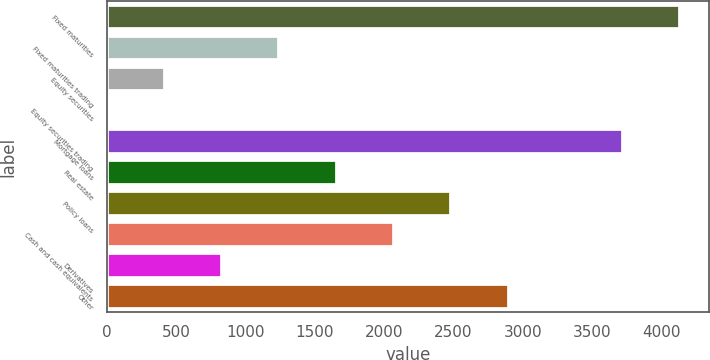Convert chart to OTSL. <chart><loc_0><loc_0><loc_500><loc_500><bar_chart><fcel>Fixed maturities<fcel>Fixed maturities trading<fcel>Equity securities<fcel>Equity securities trading<fcel>Mortgage loans<fcel>Real estate<fcel>Policy loans<fcel>Cash and cash equivalents<fcel>Derivatives<fcel>Other<nl><fcel>4138<fcel>1243.22<fcel>416.14<fcel>2.6<fcel>3724.46<fcel>1656.76<fcel>2483.84<fcel>2070.3<fcel>829.68<fcel>2897.38<nl></chart> 